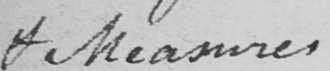What is written in this line of handwriting? & Measures 